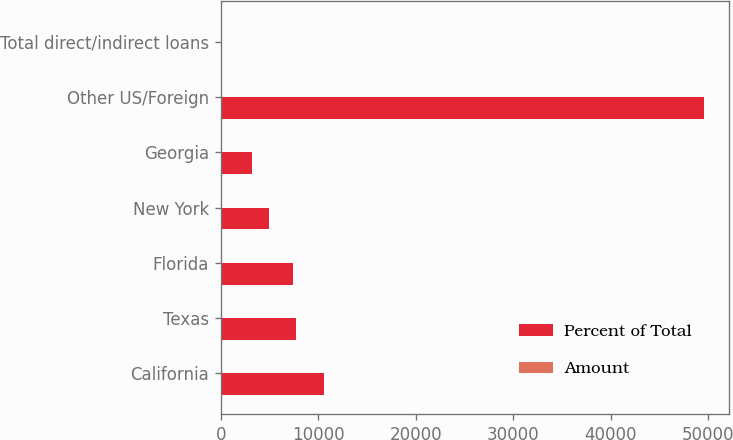Convert chart to OTSL. <chart><loc_0><loc_0><loc_500><loc_500><stacked_bar_chart><ecel><fcel>California<fcel>Texas<fcel>Florida<fcel>New York<fcel>Georgia<fcel>Other US/Foreign<fcel>Total direct/indirect loans<nl><fcel>Percent of Total<fcel>10555<fcel>7738<fcel>7376<fcel>4938<fcel>3212<fcel>49617<fcel>100<nl><fcel>Amount<fcel>12.7<fcel>9.3<fcel>8.8<fcel>5.9<fcel>3.8<fcel>59.5<fcel>100<nl></chart> 